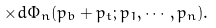Convert formula to latex. <formula><loc_0><loc_0><loc_500><loc_500>\times d \Phi _ { n } ( { p } _ { b } + { p } _ { t } ; p _ { 1 } , \cdots , p _ { n } ) .</formula> 